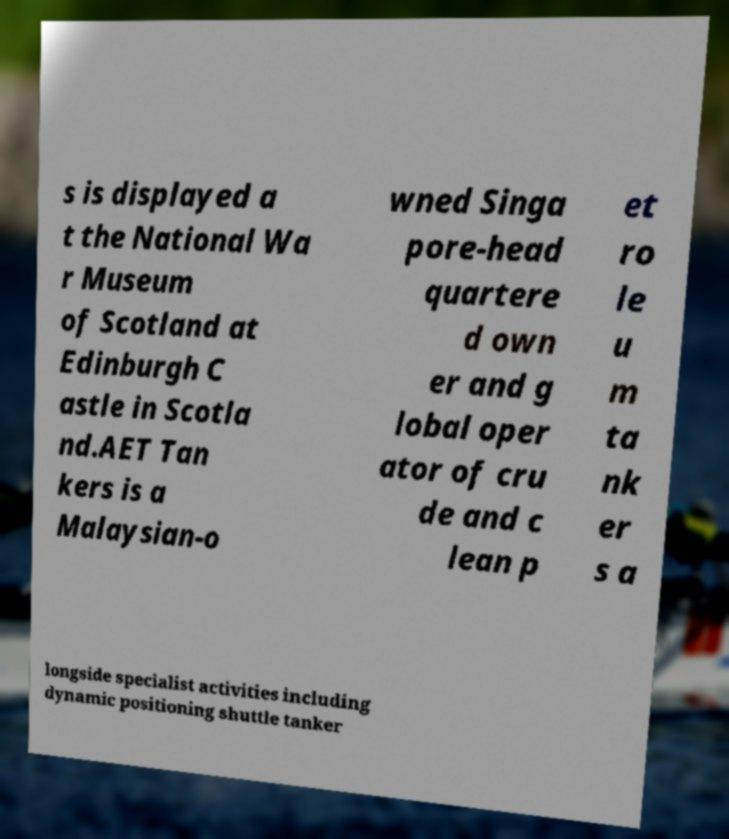Could you assist in decoding the text presented in this image and type it out clearly? s is displayed a t the National Wa r Museum of Scotland at Edinburgh C astle in Scotla nd.AET Tan kers is a Malaysian-o wned Singa pore-head quartere d own er and g lobal oper ator of cru de and c lean p et ro le u m ta nk er s a longside specialist activities including dynamic positioning shuttle tanker 